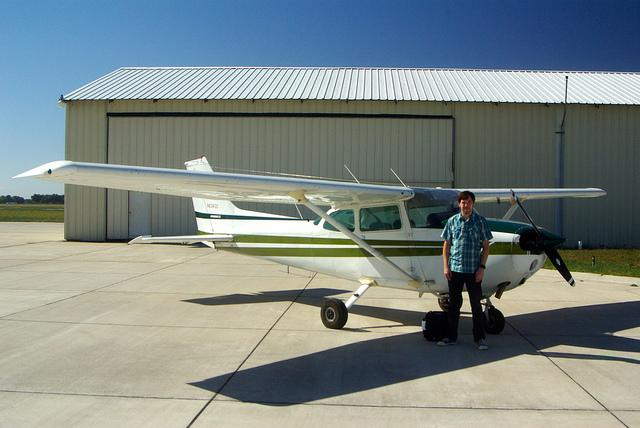Who is this person most likely to be?

Choices:
A) burglar
B) friend
C) pilot
D) buyer pilot 